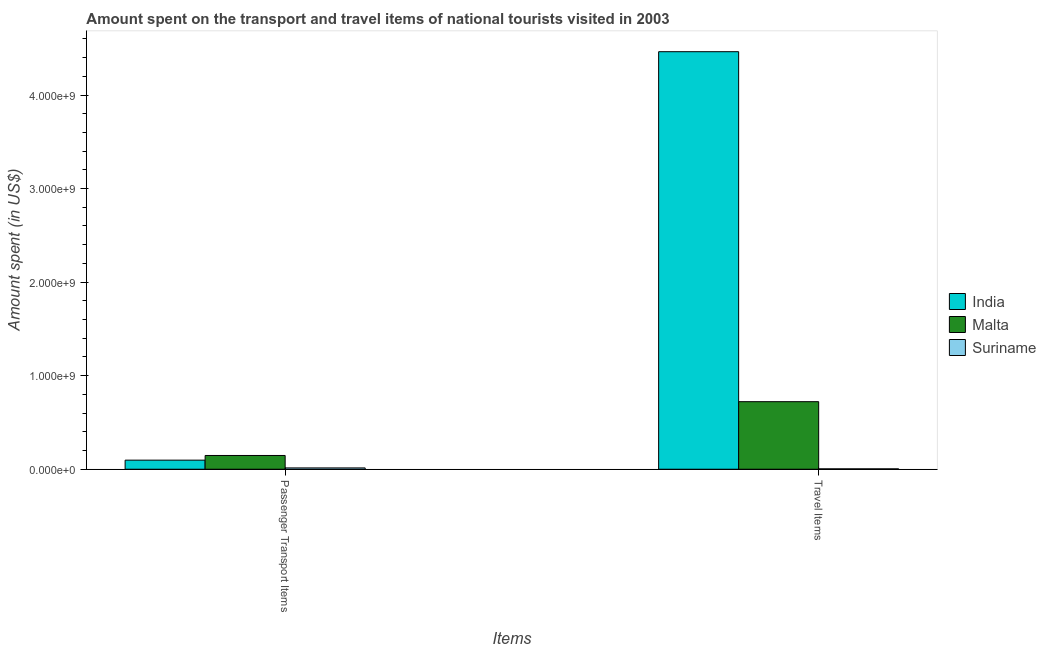How many groups of bars are there?
Your answer should be very brief. 2. Are the number of bars per tick equal to the number of legend labels?
Ensure brevity in your answer.  Yes. How many bars are there on the 1st tick from the left?
Your response must be concise. 3. How many bars are there on the 1st tick from the right?
Make the answer very short. 3. What is the label of the 1st group of bars from the left?
Your response must be concise. Passenger Transport Items. What is the amount spent on passenger transport items in India?
Provide a short and direct response. 9.70e+07. Across all countries, what is the maximum amount spent in travel items?
Provide a short and direct response. 4.46e+09. Across all countries, what is the minimum amount spent in travel items?
Ensure brevity in your answer.  4.00e+06. In which country was the amount spent in travel items maximum?
Offer a terse response. India. In which country was the amount spent on passenger transport items minimum?
Give a very brief answer. Suriname. What is the total amount spent in travel items in the graph?
Give a very brief answer. 5.19e+09. What is the difference between the amount spent on passenger transport items in Suriname and that in India?
Your answer should be compact. -8.30e+07. What is the difference between the amount spent on passenger transport items in Malta and the amount spent in travel items in Suriname?
Provide a succinct answer. 1.43e+08. What is the average amount spent in travel items per country?
Keep it short and to the point. 1.73e+09. What is the difference between the amount spent on passenger transport items and amount spent in travel items in Suriname?
Ensure brevity in your answer.  1.00e+07. What is the ratio of the amount spent in travel items in Malta to that in Suriname?
Make the answer very short. 180.5. What does the 2nd bar from the left in Passenger Transport Items represents?
Provide a succinct answer. Malta. What does the 1st bar from the right in Travel Items represents?
Provide a succinct answer. Suriname. How many countries are there in the graph?
Provide a short and direct response. 3. Are the values on the major ticks of Y-axis written in scientific E-notation?
Provide a succinct answer. Yes. Does the graph contain any zero values?
Give a very brief answer. No. Where does the legend appear in the graph?
Make the answer very short. Center right. How many legend labels are there?
Make the answer very short. 3. What is the title of the graph?
Offer a very short reply. Amount spent on the transport and travel items of national tourists visited in 2003. Does "Europe(all income levels)" appear as one of the legend labels in the graph?
Provide a succinct answer. No. What is the label or title of the X-axis?
Provide a succinct answer. Items. What is the label or title of the Y-axis?
Ensure brevity in your answer.  Amount spent (in US$). What is the Amount spent (in US$) of India in Passenger Transport Items?
Offer a terse response. 9.70e+07. What is the Amount spent (in US$) of Malta in Passenger Transport Items?
Your answer should be very brief. 1.47e+08. What is the Amount spent (in US$) of Suriname in Passenger Transport Items?
Keep it short and to the point. 1.40e+07. What is the Amount spent (in US$) of India in Travel Items?
Provide a succinct answer. 4.46e+09. What is the Amount spent (in US$) of Malta in Travel Items?
Give a very brief answer. 7.22e+08. What is the Amount spent (in US$) of Suriname in Travel Items?
Your answer should be compact. 4.00e+06. Across all Items, what is the maximum Amount spent (in US$) in India?
Your answer should be very brief. 4.46e+09. Across all Items, what is the maximum Amount spent (in US$) of Malta?
Your answer should be compact. 7.22e+08. Across all Items, what is the maximum Amount spent (in US$) in Suriname?
Your response must be concise. 1.40e+07. Across all Items, what is the minimum Amount spent (in US$) in India?
Provide a short and direct response. 9.70e+07. Across all Items, what is the minimum Amount spent (in US$) of Malta?
Give a very brief answer. 1.47e+08. What is the total Amount spent (in US$) of India in the graph?
Your answer should be compact. 4.56e+09. What is the total Amount spent (in US$) of Malta in the graph?
Keep it short and to the point. 8.69e+08. What is the total Amount spent (in US$) in Suriname in the graph?
Keep it short and to the point. 1.80e+07. What is the difference between the Amount spent (in US$) of India in Passenger Transport Items and that in Travel Items?
Your answer should be very brief. -4.37e+09. What is the difference between the Amount spent (in US$) of Malta in Passenger Transport Items and that in Travel Items?
Keep it short and to the point. -5.75e+08. What is the difference between the Amount spent (in US$) of India in Passenger Transport Items and the Amount spent (in US$) of Malta in Travel Items?
Ensure brevity in your answer.  -6.25e+08. What is the difference between the Amount spent (in US$) of India in Passenger Transport Items and the Amount spent (in US$) of Suriname in Travel Items?
Your answer should be very brief. 9.30e+07. What is the difference between the Amount spent (in US$) of Malta in Passenger Transport Items and the Amount spent (in US$) of Suriname in Travel Items?
Provide a succinct answer. 1.43e+08. What is the average Amount spent (in US$) in India per Items?
Give a very brief answer. 2.28e+09. What is the average Amount spent (in US$) of Malta per Items?
Your answer should be compact. 4.34e+08. What is the average Amount spent (in US$) in Suriname per Items?
Provide a short and direct response. 9.00e+06. What is the difference between the Amount spent (in US$) of India and Amount spent (in US$) of Malta in Passenger Transport Items?
Offer a very short reply. -5.00e+07. What is the difference between the Amount spent (in US$) of India and Amount spent (in US$) of Suriname in Passenger Transport Items?
Offer a very short reply. 8.30e+07. What is the difference between the Amount spent (in US$) in Malta and Amount spent (in US$) in Suriname in Passenger Transport Items?
Keep it short and to the point. 1.33e+08. What is the difference between the Amount spent (in US$) of India and Amount spent (in US$) of Malta in Travel Items?
Ensure brevity in your answer.  3.74e+09. What is the difference between the Amount spent (in US$) in India and Amount spent (in US$) in Suriname in Travel Items?
Your response must be concise. 4.46e+09. What is the difference between the Amount spent (in US$) of Malta and Amount spent (in US$) of Suriname in Travel Items?
Make the answer very short. 7.18e+08. What is the ratio of the Amount spent (in US$) of India in Passenger Transport Items to that in Travel Items?
Your answer should be very brief. 0.02. What is the ratio of the Amount spent (in US$) in Malta in Passenger Transport Items to that in Travel Items?
Ensure brevity in your answer.  0.2. What is the difference between the highest and the second highest Amount spent (in US$) of India?
Offer a terse response. 4.37e+09. What is the difference between the highest and the second highest Amount spent (in US$) in Malta?
Offer a terse response. 5.75e+08. What is the difference between the highest and the second highest Amount spent (in US$) of Suriname?
Offer a terse response. 1.00e+07. What is the difference between the highest and the lowest Amount spent (in US$) of India?
Give a very brief answer. 4.37e+09. What is the difference between the highest and the lowest Amount spent (in US$) in Malta?
Offer a terse response. 5.75e+08. 